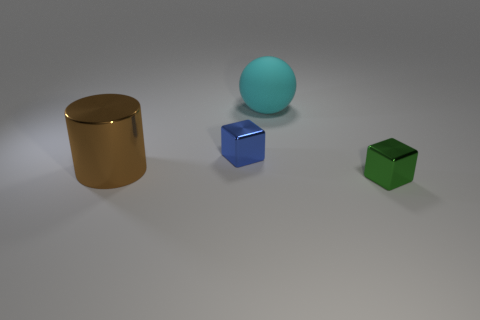Subtract all purple cubes. Subtract all yellow balls. How many cubes are left? 2 Add 1 small shiny blocks. How many objects exist? 5 Subtract all balls. How many objects are left? 3 Add 4 large matte spheres. How many large matte spheres are left? 5 Add 4 big balls. How many big balls exist? 5 Subtract 0 purple blocks. How many objects are left? 4 Subtract all green cubes. Subtract all rubber spheres. How many objects are left? 2 